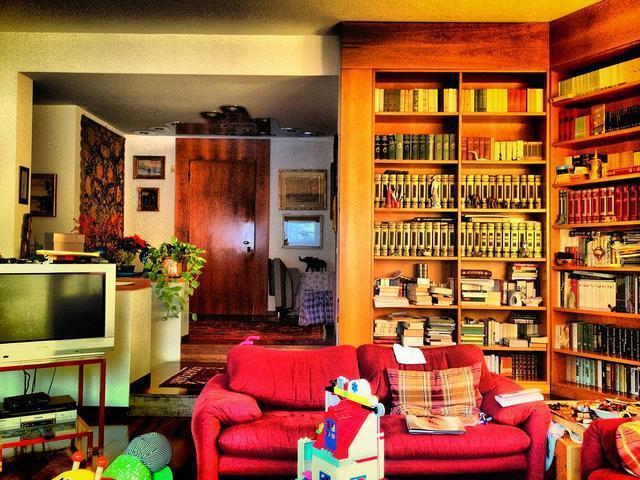How many books are visible?
Give a very brief answer. 1. 